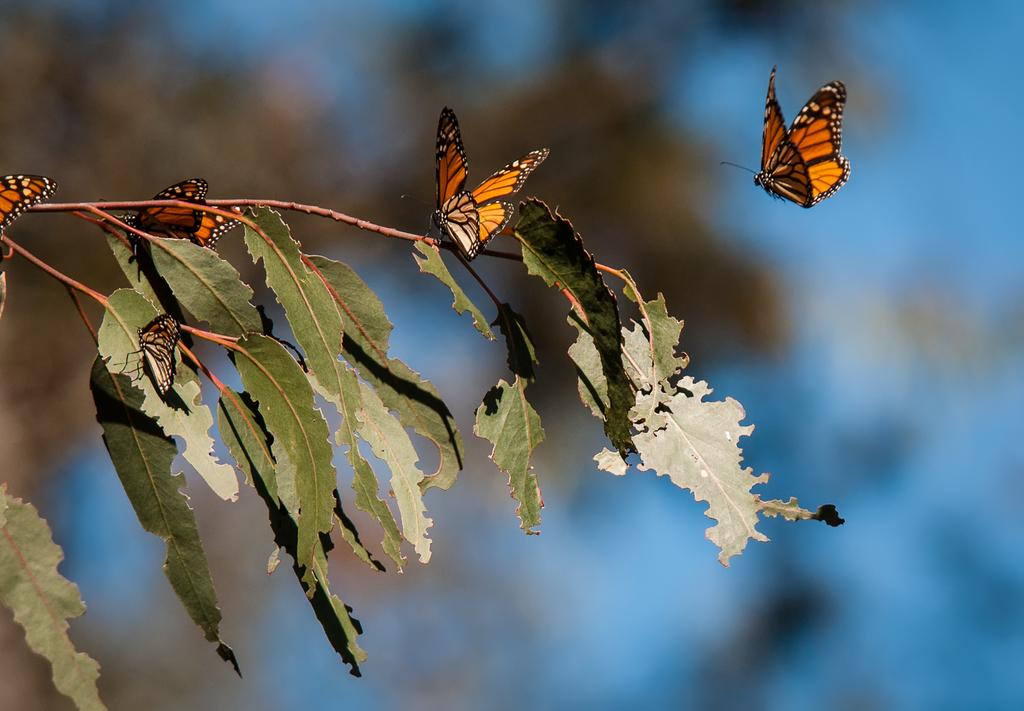What type of animals are on the branch in the image? There are butterflies on a branch in the image. What else can be seen on the branch besides the butterflies? Leaves are visible in the image. What is located in the background of the image? There appears to be a tree in the background of the image. Where is the plastic nest located in the image? There is no plastic nest present in the image. 